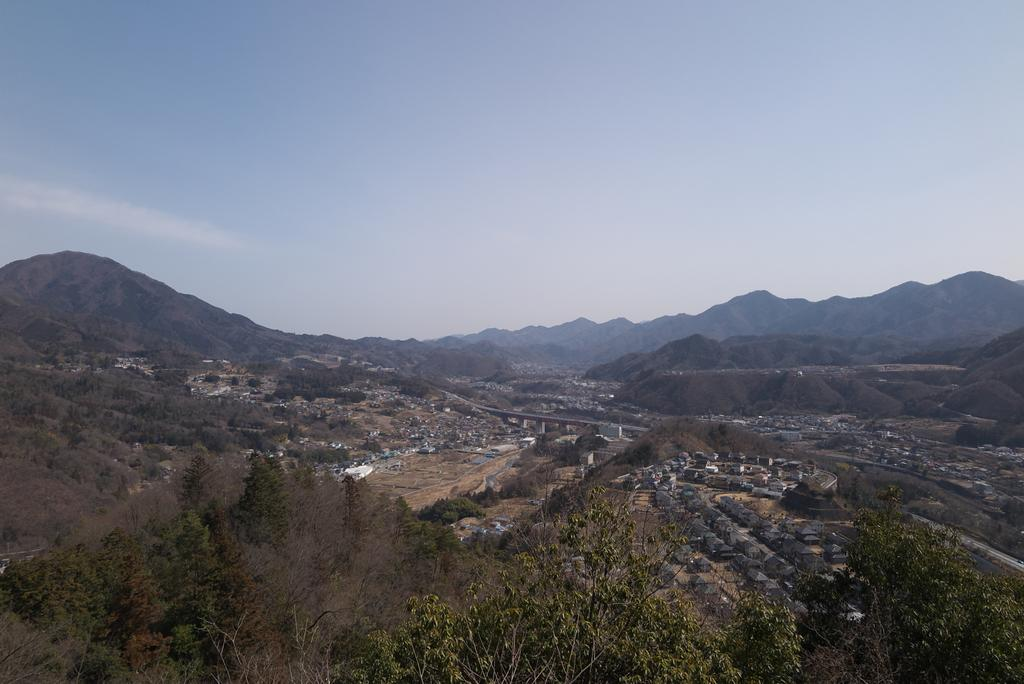What type of natural elements can be seen in the image? There are trees in the image. What man-made structure is present in the image? There is a bridge in the image. What type of human-made structures can be seen on the ground in the image? There are buildings on the ground in the image. What type of geographical feature can be seen in the background of the image? There are mountains in the background of the image. What is visible in the sky in the image? There are clouds in the sky in the image. How many pets are visible in the image? There are no pets present in the image. What type of tool is being used to wash the trees in the image? There is no tool being used to wash the trees in the image, as trees do not require washing. 